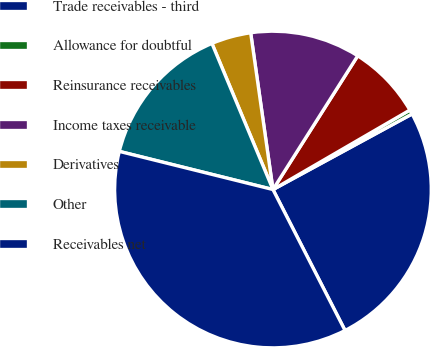Convert chart. <chart><loc_0><loc_0><loc_500><loc_500><pie_chart><fcel>Trade receivables - third<fcel>Allowance for doubtful<fcel>Reinsurance receivables<fcel>Income taxes receivable<fcel>Derivatives<fcel>Other<fcel>Receivables net<nl><fcel>25.4%<fcel>0.45%<fcel>7.64%<fcel>11.24%<fcel>4.05%<fcel>14.83%<fcel>36.4%<nl></chart> 